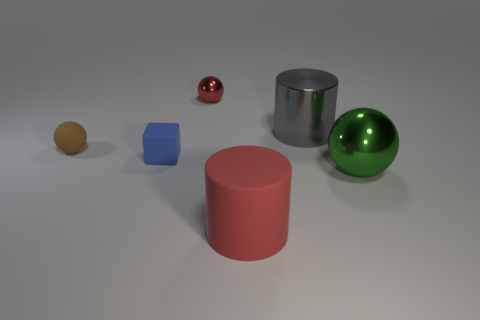What can you infer about the lighting in this scene? The lighting in the scene appears to be soft and diffused, coming from above and casting gentle shadows directly underneath the objects. This suggests an indoor setting, possibly with multiple light sources to create such even illumination without harsh shadows. 